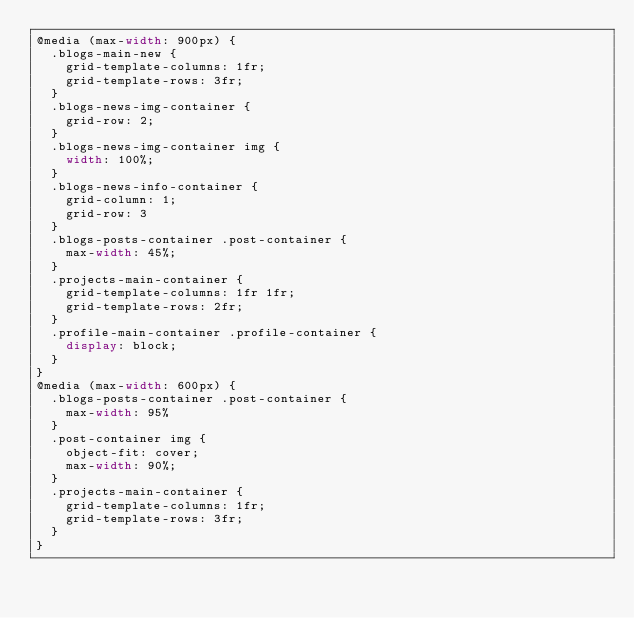<code> <loc_0><loc_0><loc_500><loc_500><_CSS_>@media (max-width: 900px) {
  .blogs-main-new {
    grid-template-columns: 1fr;
    grid-template-rows: 3fr;
  }
  .blogs-news-img-container {
    grid-row: 2;
  }
  .blogs-news-img-container img {
    width: 100%;
  }
  .blogs-news-info-container {
    grid-column: 1;
    grid-row: 3
  }
  .blogs-posts-container .post-container {
    max-width: 45%;
  }
  .projects-main-container {
    grid-template-columns: 1fr 1fr;
    grid-template-rows: 2fr;
  }
  .profile-main-container .profile-container {
    display: block;
  }
}
@media (max-width: 600px) {
  .blogs-posts-container .post-container {
    max-width: 95%
  }
  .post-container img {
    object-fit: cover;
    max-width: 90%;
  }
  .projects-main-container {
    grid-template-columns: 1fr;
    grid-template-rows: 3fr;
  }
}</code> 